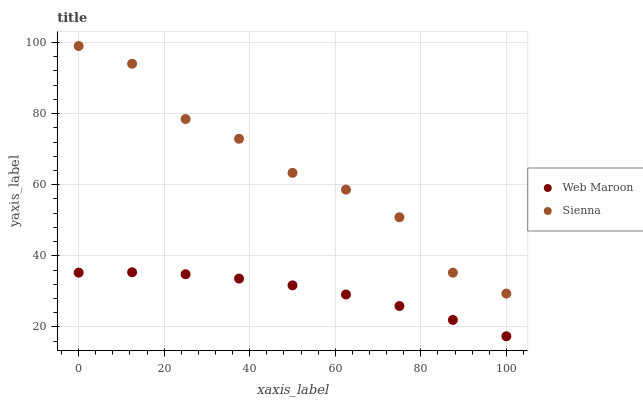Does Web Maroon have the minimum area under the curve?
Answer yes or no. Yes. Does Sienna have the maximum area under the curve?
Answer yes or no. Yes. Does Web Maroon have the maximum area under the curve?
Answer yes or no. No. Is Web Maroon the smoothest?
Answer yes or no. Yes. Is Sienna the roughest?
Answer yes or no. Yes. Is Web Maroon the roughest?
Answer yes or no. No. Does Web Maroon have the lowest value?
Answer yes or no. Yes. Does Sienna have the highest value?
Answer yes or no. Yes. Does Web Maroon have the highest value?
Answer yes or no. No. Is Web Maroon less than Sienna?
Answer yes or no. Yes. Is Sienna greater than Web Maroon?
Answer yes or no. Yes. Does Web Maroon intersect Sienna?
Answer yes or no. No. 